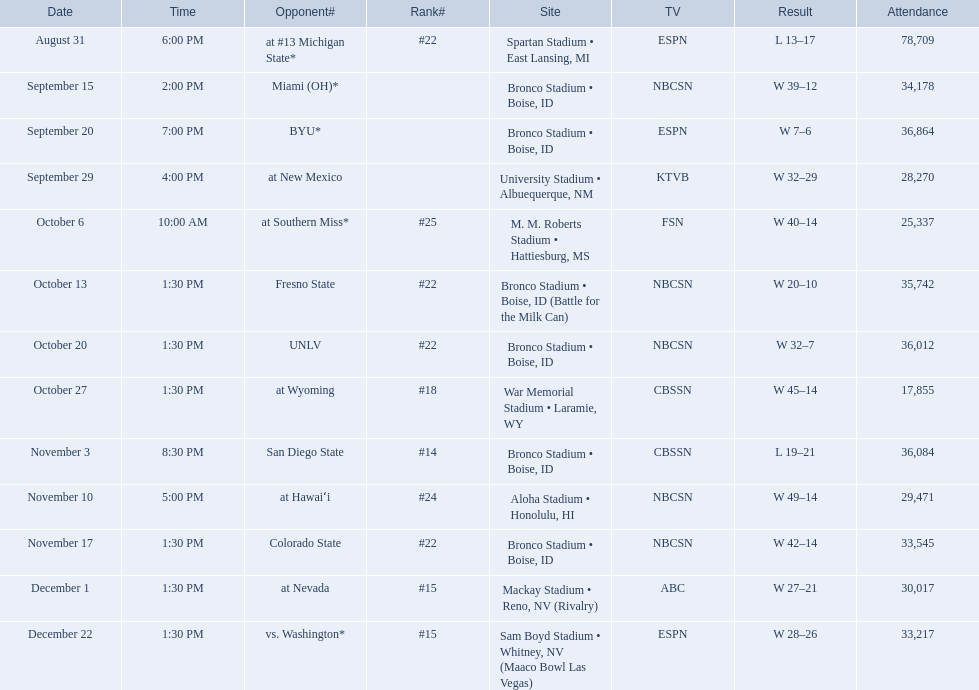Who were all the competitors for boise state? At #13 michigan state*, miami (oh)*, byu*, at new mexico, at southern miss*, fresno state, unlv, at wyoming, san diego state, at hawaiʻi, colorado state, at nevada, vs. washington*. Which competitors were ranked? At #13 michigan state*, #22, at southern miss*, #25, fresno state, #22, unlv, #22, at wyoming, #18, san diego state, #14. Which competitor had the highest rank? San Diego State. 